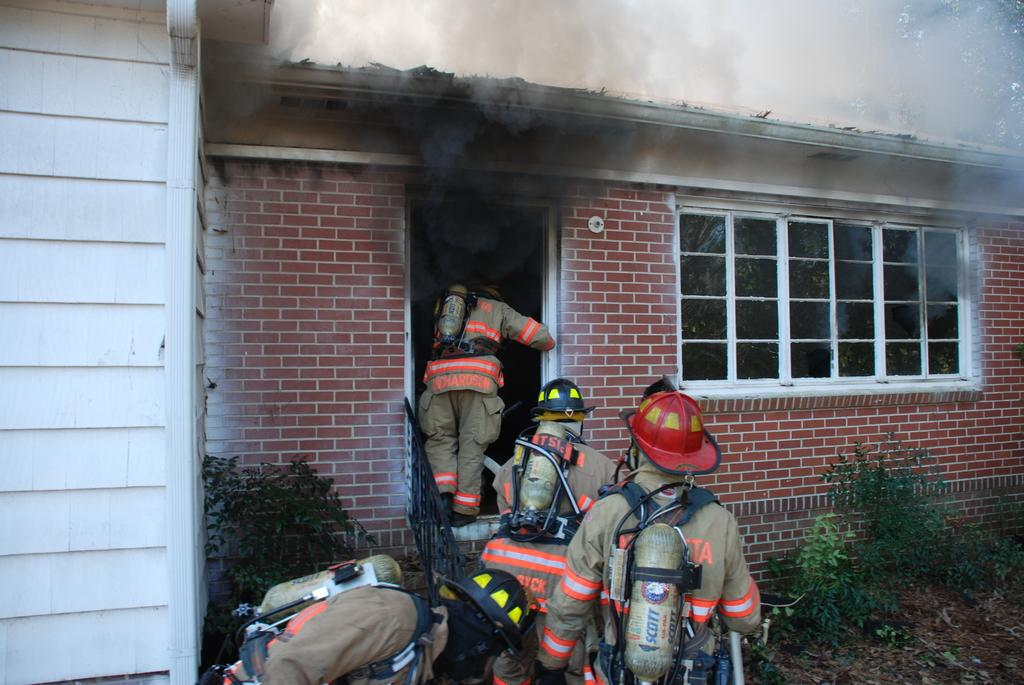How many people are in the image? There are people in the image, but the exact number is not specified. What are the people holding in the image? The people are holding cylinders in the image. What type of natural environment is visible in the image? There is grass and a tree in the image, indicating a natural environment. What type of structure is present in the image? There is a house in the image. What is happening with the house in the image? Smoke is coming from the house in the image. What else can be seen in the image besides the people and the house? There are plants in the image. What type of knife is being used to cut the yoke in the image? There is no knife or yoke present in the image. 